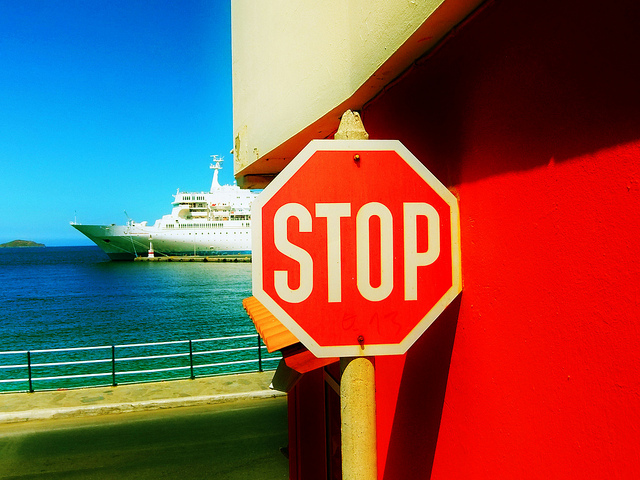Please identify all text content in this image. STOP 